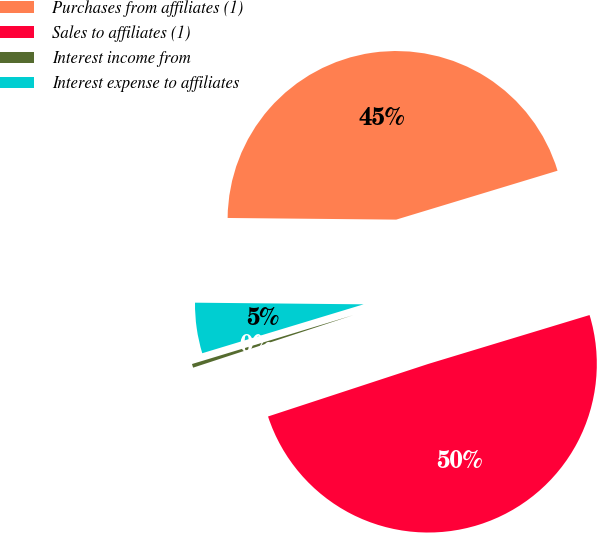Convert chart to OTSL. <chart><loc_0><loc_0><loc_500><loc_500><pie_chart><fcel>Purchases from affiliates (1)<fcel>Sales to affiliates (1)<fcel>Interest income from<fcel>Interest expense to affiliates<nl><fcel>45.16%<fcel>49.64%<fcel>0.36%<fcel>4.84%<nl></chart> 